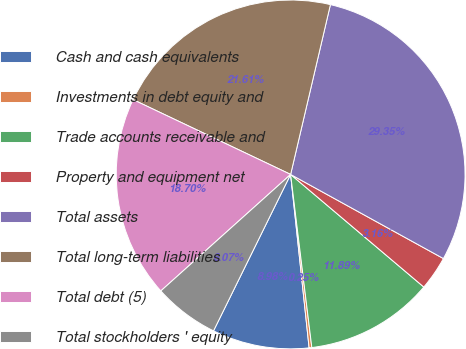Convert chart. <chart><loc_0><loc_0><loc_500><loc_500><pie_chart><fcel>Cash and cash equivalents<fcel>Investments in debt equity and<fcel>Trade accounts receivable and<fcel>Property and equipment net<fcel>Total assets<fcel>Total long-term liabilities<fcel>Total debt (5)<fcel>Total stockholders ' equity<nl><fcel>8.98%<fcel>0.25%<fcel>11.89%<fcel>3.16%<fcel>29.35%<fcel>21.61%<fcel>18.7%<fcel>6.07%<nl></chart> 